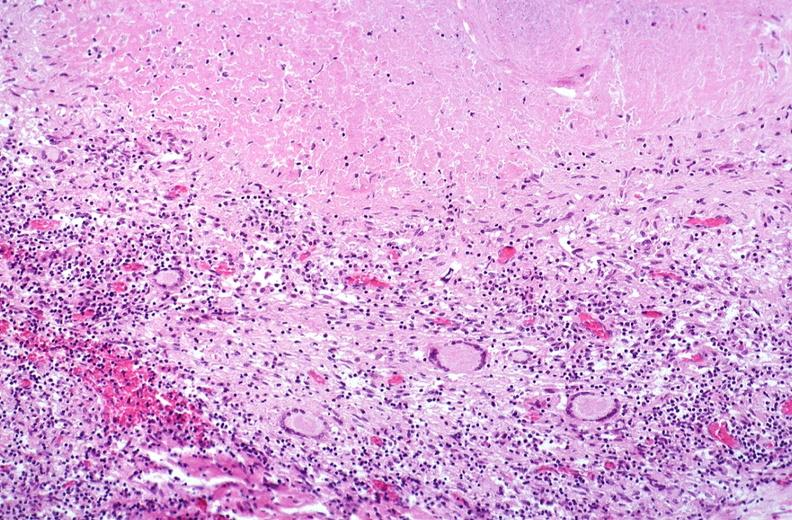what is present?
Answer the question using a single word or phrase. Respiratory 